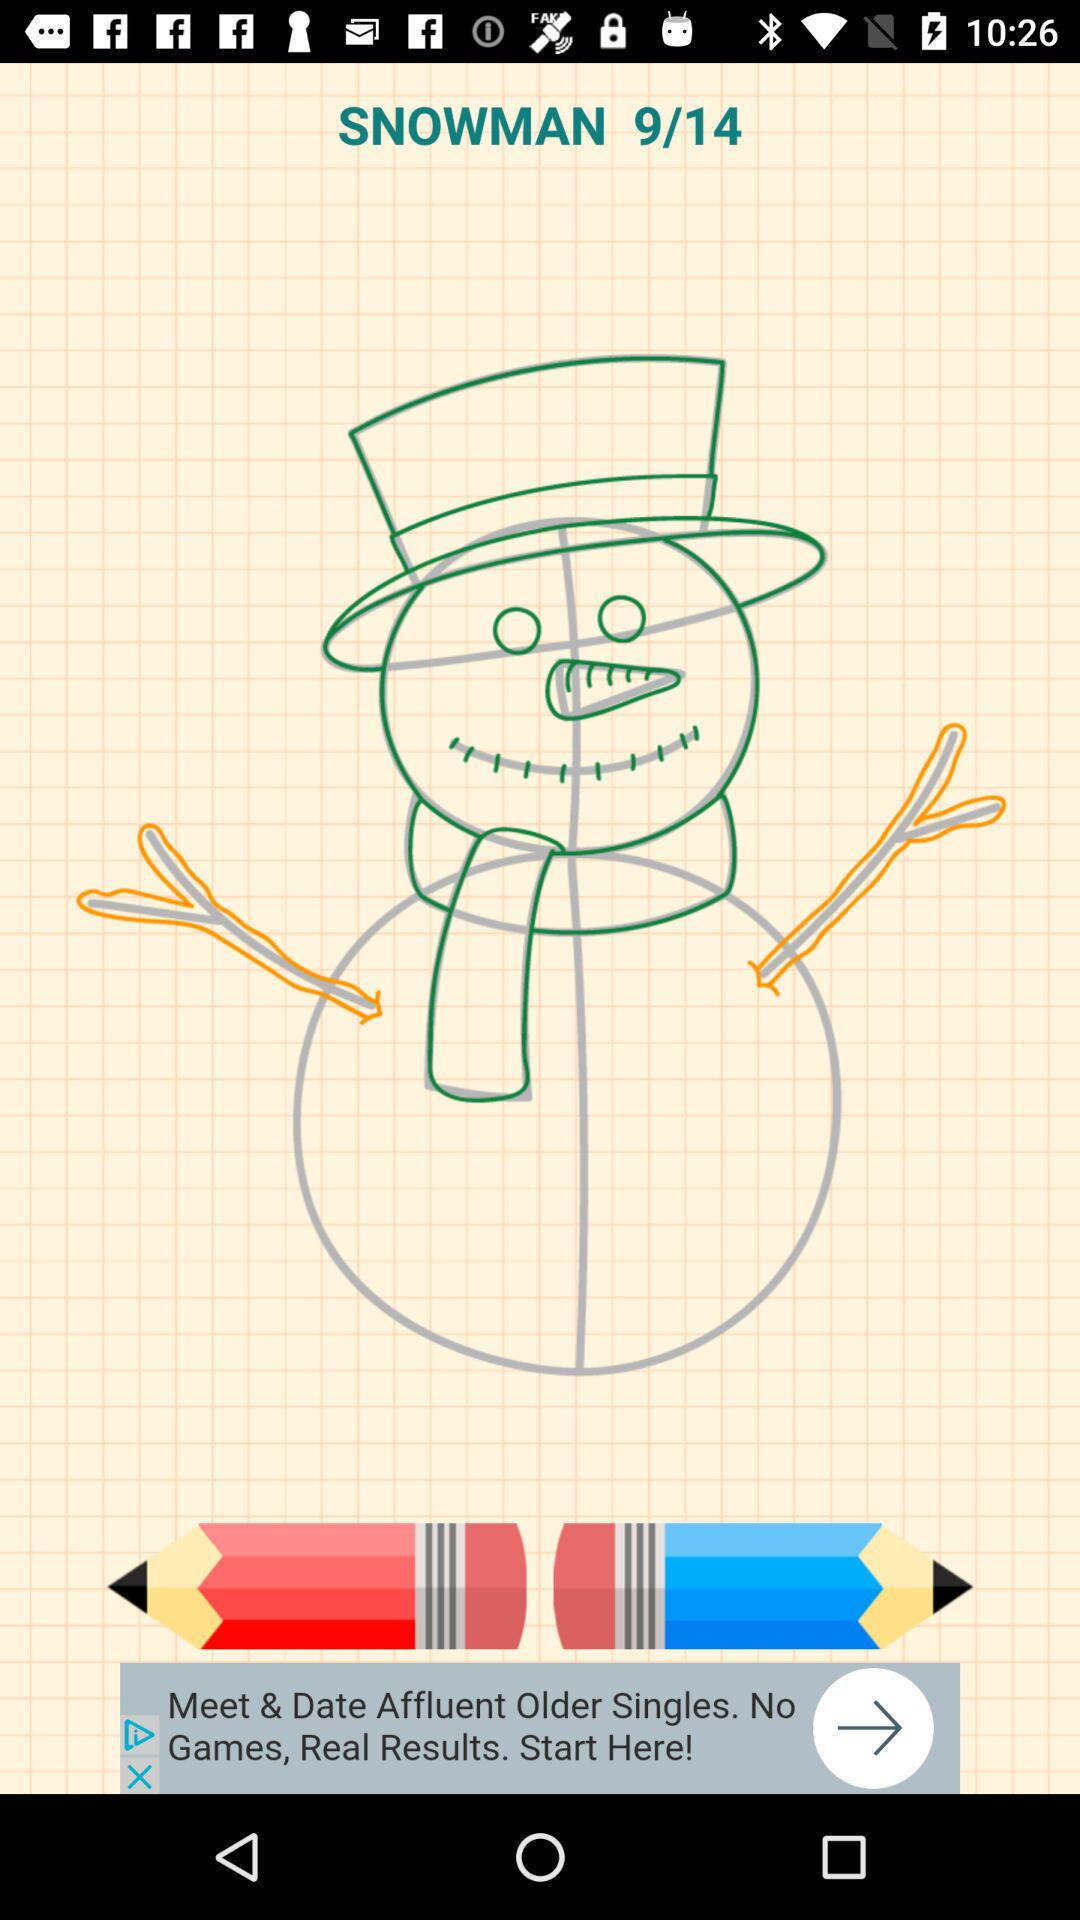Which page am I on? You are on the 9th page. 